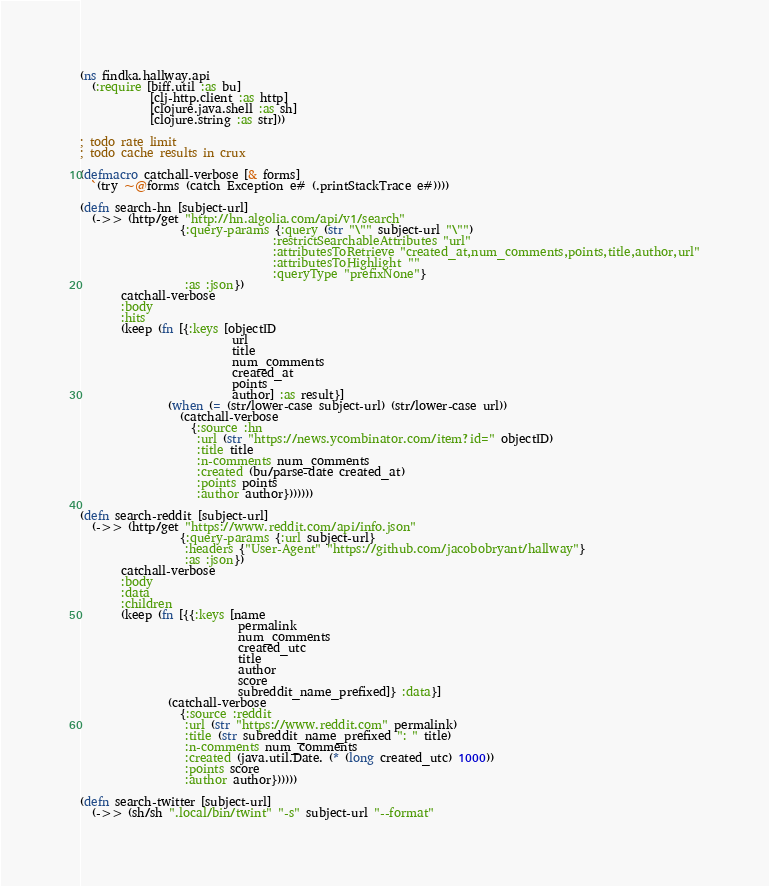<code> <loc_0><loc_0><loc_500><loc_500><_Clojure_>(ns findka.hallway.api
  (:require [biff.util :as bu]
            [clj-http.client :as http]
            [clojure.java.shell :as sh]
            [clojure.string :as str]))

; todo rate limit
; todo cache results in crux

(defmacro catchall-verbose [& forms]
  `(try ~@forms (catch Exception e# (.printStackTrace e#))))

(defn search-hn [subject-url]
  (->> (http/get "http://hn.algolia.com/api/v1/search"
                 {:query-params {:query (str "\"" subject-url "\"")
                                 :restrictSearchableAttributes "url"
                                 :attributesToRetrieve "created_at,num_comments,points,title,author,url"
                                 :attributesToHighlight ""
                                 :queryType "prefixNone"}
                  :as :json})
       catchall-verbose
       :body
       :hits
       (keep (fn [{:keys [objectID
                          url
                          title
                          num_comments
                          created_at
                          points
                          author] :as result}]
               (when (= (str/lower-case subject-url) (str/lower-case url))
                 (catchall-verbose
                   {:source :hn
                    :url (str "https://news.ycombinator.com/item?id=" objectID)
                    :title title
                    :n-comments num_comments
                    :created (bu/parse-date created_at)
                    :points points
                    :author author}))))))

(defn search-reddit [subject-url]
  (->> (http/get "https://www.reddit.com/api/info.json"
                 {:query-params {:url subject-url}
                  :headers {"User-Agent" "https://github.com/jacobobryant/hallway"}
                  :as :json})
       catchall-verbose
       :body
       :data
       :children
       (keep (fn [{{:keys [name
                           permalink
                           num_comments
                           created_utc
                           title
                           author
                           score
                           subreddit_name_prefixed]} :data}]
               (catchall-verbose
                 {:source :reddit
                  :url (str "https://www.reddit.com" permalink)
                  :title (str subreddit_name_prefixed ": " title)
                  :n-comments num_comments
                  :created (java.util.Date. (* (long created_utc) 1000))
                  :points score
                  :author author})))))

(defn search-twitter [subject-url]
  (->> (sh/sh ".local/bin/twint" "-s" subject-url "--format"</code> 